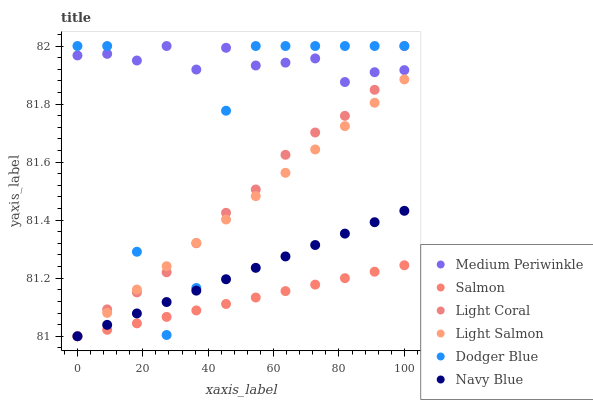Does Salmon have the minimum area under the curve?
Answer yes or no. Yes. Does Medium Periwinkle have the maximum area under the curve?
Answer yes or no. Yes. Does Medium Periwinkle have the minimum area under the curve?
Answer yes or no. No. Does Salmon have the maximum area under the curve?
Answer yes or no. No. Is Navy Blue the smoothest?
Answer yes or no. Yes. Is Dodger Blue the roughest?
Answer yes or no. Yes. Is Medium Periwinkle the smoothest?
Answer yes or no. No. Is Medium Periwinkle the roughest?
Answer yes or no. No. Does Light Salmon have the lowest value?
Answer yes or no. Yes. Does Medium Periwinkle have the lowest value?
Answer yes or no. No. Does Dodger Blue have the highest value?
Answer yes or no. Yes. Does Salmon have the highest value?
Answer yes or no. No. Is Navy Blue less than Medium Periwinkle?
Answer yes or no. Yes. Is Medium Periwinkle greater than Salmon?
Answer yes or no. Yes. Does Salmon intersect Light Salmon?
Answer yes or no. Yes. Is Salmon less than Light Salmon?
Answer yes or no. No. Is Salmon greater than Light Salmon?
Answer yes or no. No. Does Navy Blue intersect Medium Periwinkle?
Answer yes or no. No. 